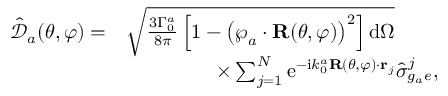Convert formula to latex. <formula><loc_0><loc_0><loc_500><loc_500>\begin{array} { r l } { \mathcal { \hat { \mathcal { D } } } _ { a } ( \theta , \varphi ) = } & { \sqrt { \frac { 3 \Gamma _ { 0 } ^ { a } } { 8 \pi } \left [ 1 - \left ( \wp _ { a } \cdot R ( \theta , \varphi ) \right ) ^ { 2 } \right ] d \Omega } } \\ & { \, \times \sum _ { j = 1 } ^ { N } e ^ { - i k _ { 0 } ^ { a } R ( \theta , \varphi ) \cdot { r } _ { j } } \hat { \sigma } _ { g _ { a } e } ^ { j } , } \end{array}</formula> 